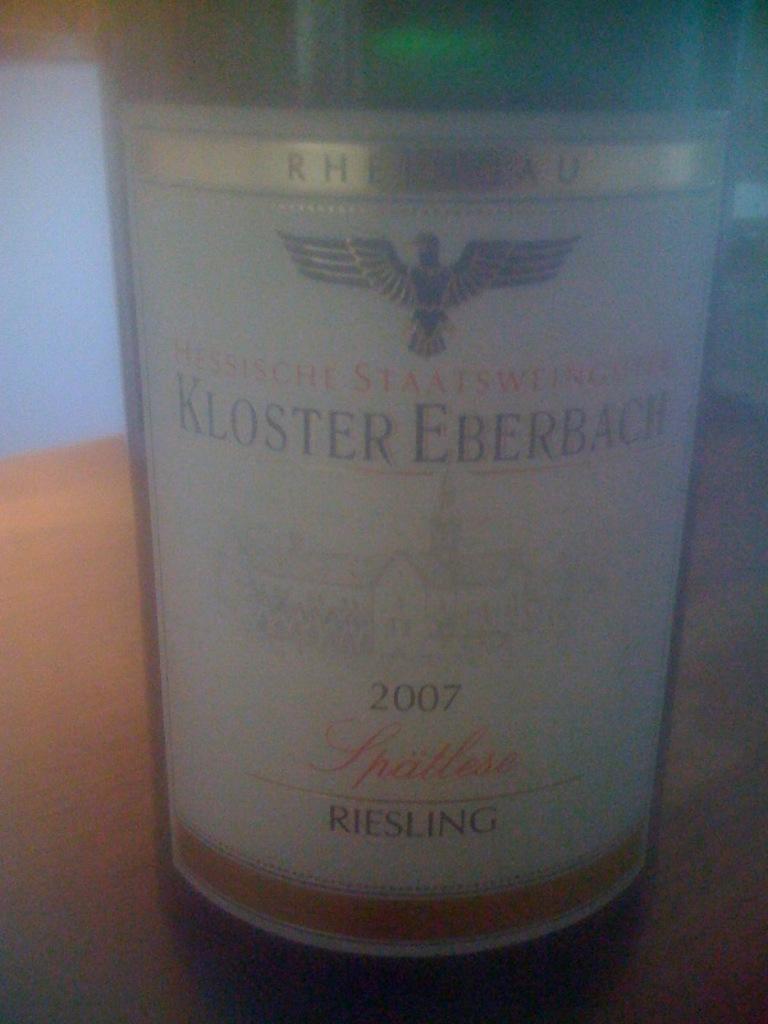What type of wine is this?
Provide a succinct answer. Riesling. What is the year of this wine?
Your answer should be very brief. 2007. 